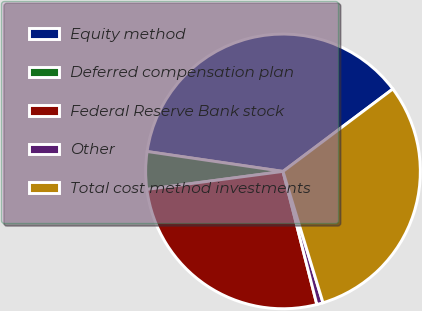Convert chart to OTSL. <chart><loc_0><loc_0><loc_500><loc_500><pie_chart><fcel>Equity method<fcel>Deferred compensation plan<fcel>Federal Reserve Bank stock<fcel>Other<fcel>Total cost method investments<nl><fcel>37.44%<fcel>4.41%<fcel>26.87%<fcel>0.74%<fcel>30.54%<nl></chart> 